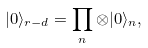<formula> <loc_0><loc_0><loc_500><loc_500>| 0 \rangle _ { r - d } = \prod _ { n } \otimes | 0 \rangle _ { n } ,</formula> 